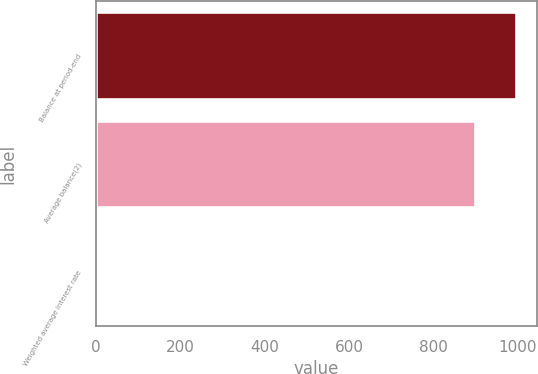<chart> <loc_0><loc_0><loc_500><loc_500><bar_chart><fcel>Balance at period-end<fcel>Average balance(2)<fcel>Weighted average interest rate<nl><fcel>996.53<fcel>899<fcel>2.7<nl></chart> 